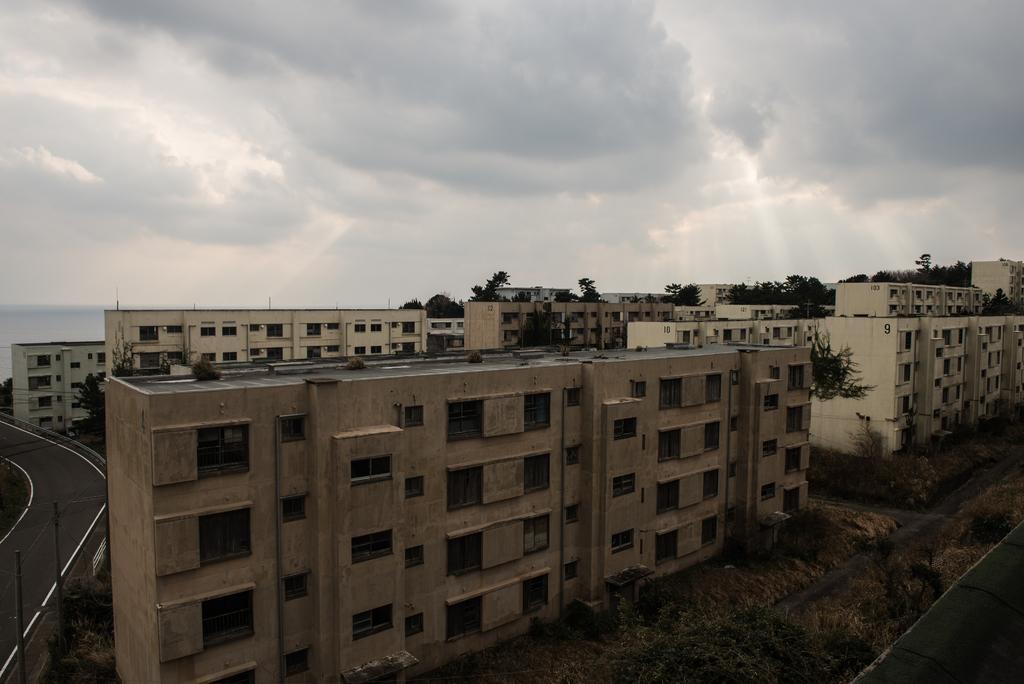In one or two sentences, can you explain what this image depicts? This image is taken outdoors. At the top of the image there is the sky with clouds. At the bottom of the image there is a ground with grass on it and there are a few plants and trees on the ground. At the right bottom of the image there is a road. In the middle of the image there are a few buildings with walls, windows, roofs and doors. There are many trees. On the left side of the image there is a road and there are two poles with street lights. 